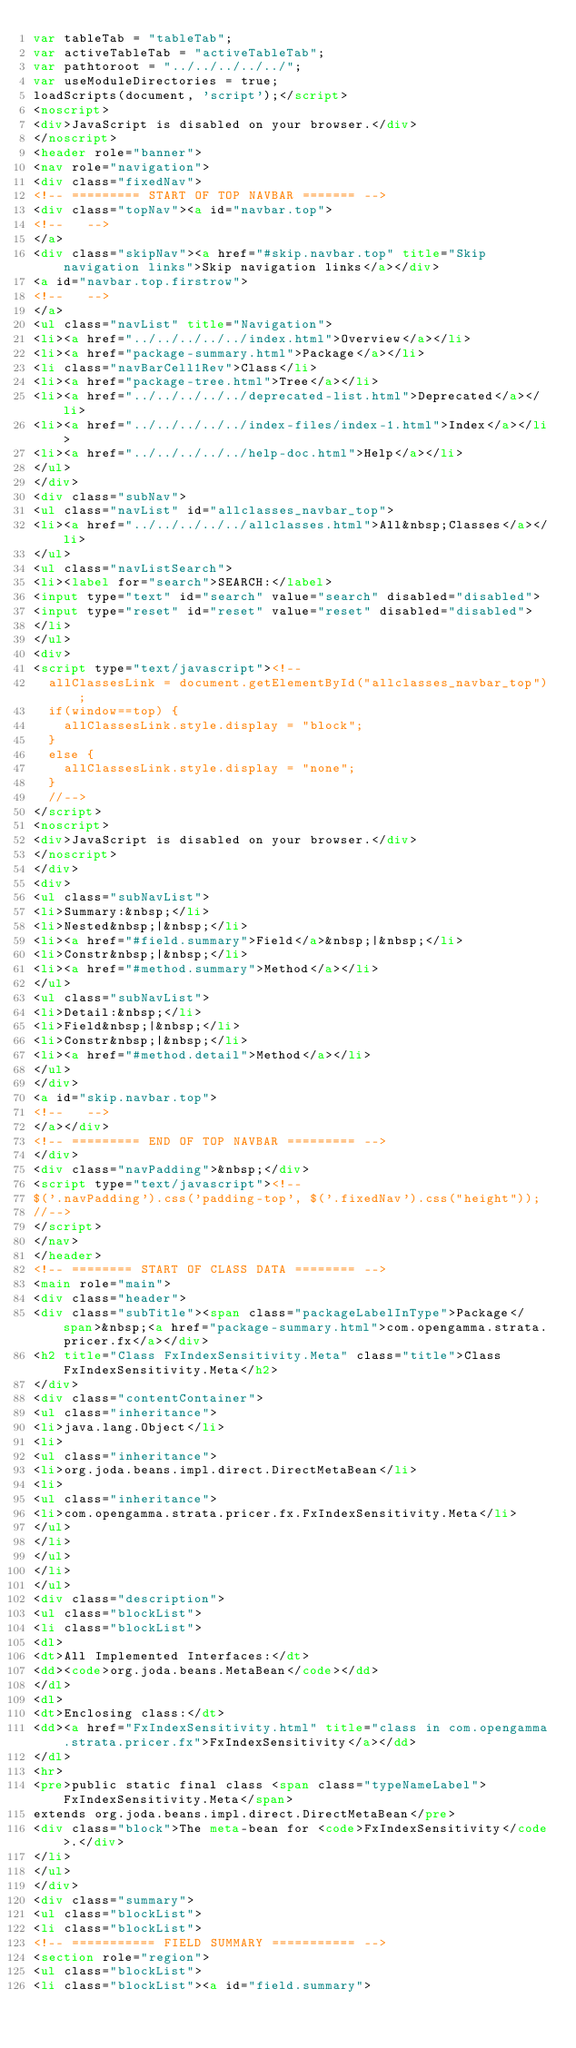<code> <loc_0><loc_0><loc_500><loc_500><_HTML_>var tableTab = "tableTab";
var activeTableTab = "activeTableTab";
var pathtoroot = "../../../../../";
var useModuleDirectories = true;
loadScripts(document, 'script');</script>
<noscript>
<div>JavaScript is disabled on your browser.</div>
</noscript>
<header role="banner">
<nav role="navigation">
<div class="fixedNav">
<!-- ========= START OF TOP NAVBAR ======= -->
<div class="topNav"><a id="navbar.top">
<!--   -->
</a>
<div class="skipNav"><a href="#skip.navbar.top" title="Skip navigation links">Skip navigation links</a></div>
<a id="navbar.top.firstrow">
<!--   -->
</a>
<ul class="navList" title="Navigation">
<li><a href="../../../../../index.html">Overview</a></li>
<li><a href="package-summary.html">Package</a></li>
<li class="navBarCell1Rev">Class</li>
<li><a href="package-tree.html">Tree</a></li>
<li><a href="../../../../../deprecated-list.html">Deprecated</a></li>
<li><a href="../../../../../index-files/index-1.html">Index</a></li>
<li><a href="../../../../../help-doc.html">Help</a></li>
</ul>
</div>
<div class="subNav">
<ul class="navList" id="allclasses_navbar_top">
<li><a href="../../../../../allclasses.html">All&nbsp;Classes</a></li>
</ul>
<ul class="navListSearch">
<li><label for="search">SEARCH:</label>
<input type="text" id="search" value="search" disabled="disabled">
<input type="reset" id="reset" value="reset" disabled="disabled">
</li>
</ul>
<div>
<script type="text/javascript"><!--
  allClassesLink = document.getElementById("allclasses_navbar_top");
  if(window==top) {
    allClassesLink.style.display = "block";
  }
  else {
    allClassesLink.style.display = "none";
  }
  //-->
</script>
<noscript>
<div>JavaScript is disabled on your browser.</div>
</noscript>
</div>
<div>
<ul class="subNavList">
<li>Summary:&nbsp;</li>
<li>Nested&nbsp;|&nbsp;</li>
<li><a href="#field.summary">Field</a>&nbsp;|&nbsp;</li>
<li>Constr&nbsp;|&nbsp;</li>
<li><a href="#method.summary">Method</a></li>
</ul>
<ul class="subNavList">
<li>Detail:&nbsp;</li>
<li>Field&nbsp;|&nbsp;</li>
<li>Constr&nbsp;|&nbsp;</li>
<li><a href="#method.detail">Method</a></li>
</ul>
</div>
<a id="skip.navbar.top">
<!--   -->
</a></div>
<!-- ========= END OF TOP NAVBAR ========= -->
</div>
<div class="navPadding">&nbsp;</div>
<script type="text/javascript"><!--
$('.navPadding').css('padding-top', $('.fixedNav').css("height"));
//-->
</script>
</nav>
</header>
<!-- ======== START OF CLASS DATA ======== -->
<main role="main">
<div class="header">
<div class="subTitle"><span class="packageLabelInType">Package</span>&nbsp;<a href="package-summary.html">com.opengamma.strata.pricer.fx</a></div>
<h2 title="Class FxIndexSensitivity.Meta" class="title">Class FxIndexSensitivity.Meta</h2>
</div>
<div class="contentContainer">
<ul class="inheritance">
<li>java.lang.Object</li>
<li>
<ul class="inheritance">
<li>org.joda.beans.impl.direct.DirectMetaBean</li>
<li>
<ul class="inheritance">
<li>com.opengamma.strata.pricer.fx.FxIndexSensitivity.Meta</li>
</ul>
</li>
</ul>
</li>
</ul>
<div class="description">
<ul class="blockList">
<li class="blockList">
<dl>
<dt>All Implemented Interfaces:</dt>
<dd><code>org.joda.beans.MetaBean</code></dd>
</dl>
<dl>
<dt>Enclosing class:</dt>
<dd><a href="FxIndexSensitivity.html" title="class in com.opengamma.strata.pricer.fx">FxIndexSensitivity</a></dd>
</dl>
<hr>
<pre>public static final class <span class="typeNameLabel">FxIndexSensitivity.Meta</span>
extends org.joda.beans.impl.direct.DirectMetaBean</pre>
<div class="block">The meta-bean for <code>FxIndexSensitivity</code>.</div>
</li>
</ul>
</div>
<div class="summary">
<ul class="blockList">
<li class="blockList">
<!-- =========== FIELD SUMMARY =========== -->
<section role="region">
<ul class="blockList">
<li class="blockList"><a id="field.summary"></code> 